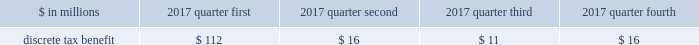Notes to consolidated financial statements 4 .
The sum of the quarters 2019 earnings per common share may not equal the annual amounts due to the averaging effect of the number of shares and share equivalents throughout the year .
During the fourth quarter of 2016 , net revenues included losses of approximately $ 60 million on sales and markdowns of legacy limited partnership investments in third-party-sponsored funds within the invest- ment management business segment .
The fourth quarter of 2016 also included a $ 70 million provision within the wealth management busi- ness segment related to certain brokerage service reporting activities .
Employee share-based awards .
24 .
Subsequent events the firm has evaluated subsequent events for adjustment to or disclosure in the financial statements through the date of this report and has not identified any recordable or disclos- able events not otherwise reported in these financial state- ments or the notes thereto .
175 december 2017 form 10-k .
What was the total discrete tax benefit from employee share-based awards in 2017 in millions? 
Computations: (((112 + 16) + 11) + 16)
Answer: 155.0. 